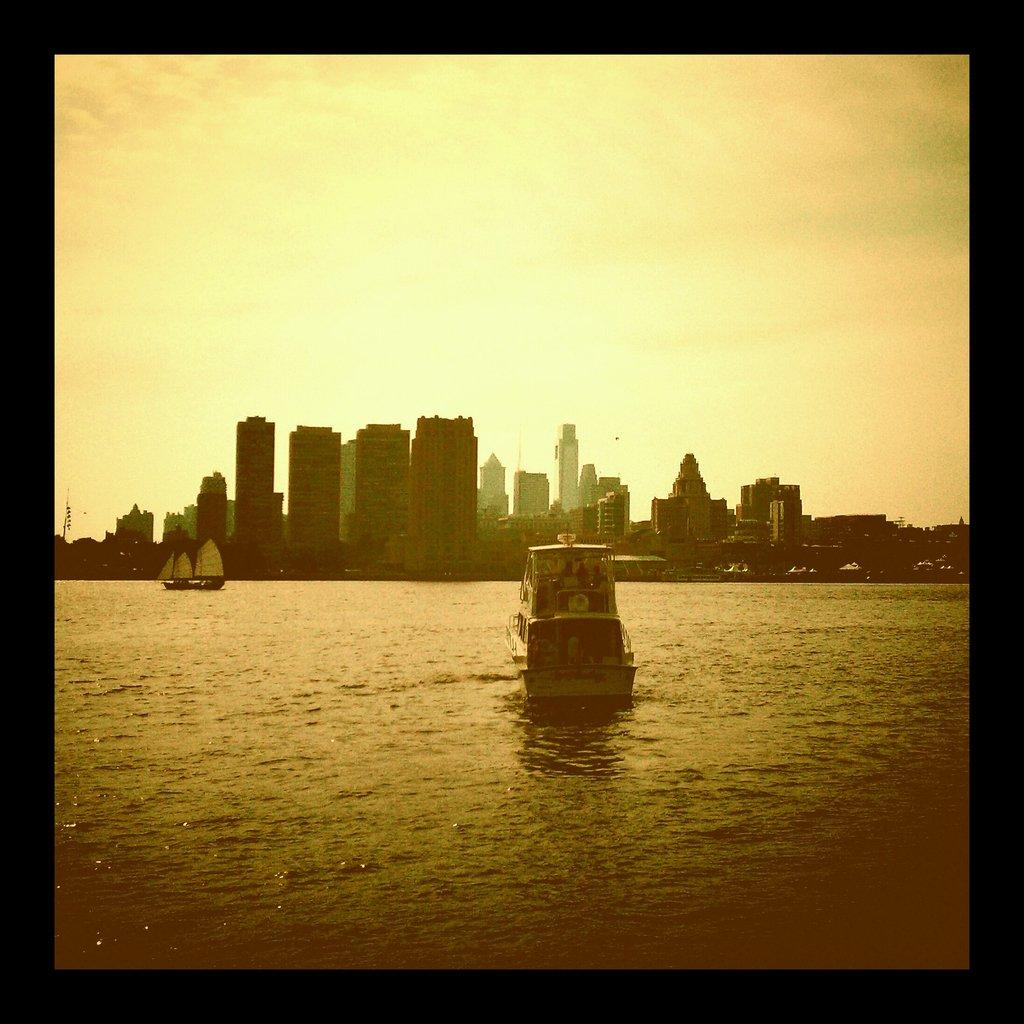What is the main subject of the image? The main subject of the image is boats on water. What else can be seen in the image besides the boats? There are buildings visible in the image, and the sky is visible in the background. What is the condition of the sky in the image? The sky is visible in the background, and clouds are present. Can you tell me how many bones are visible in the image? There are no bones present in the image; it features boats on water, buildings, and a sky with clouds. What type of dog can be seen playing with a bag in the image? There is no dog or bag present in the image. 